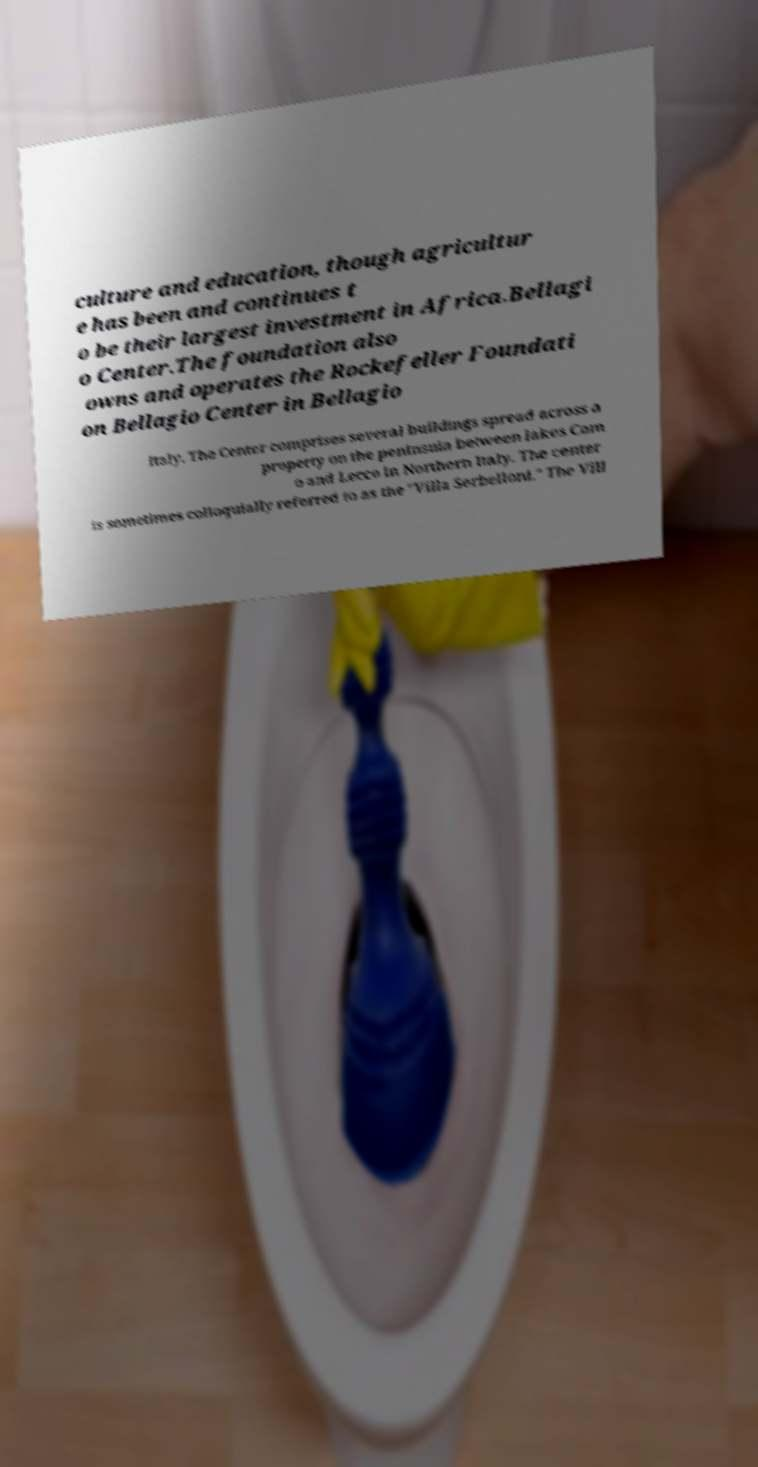Please identify and transcribe the text found in this image. culture and education, though agricultur e has been and continues t o be their largest investment in Africa.Bellagi o Center.The foundation also owns and operates the Rockefeller Foundati on Bellagio Center in Bellagio Italy. The Center comprises several buildings spread across a property on the peninsula between lakes Com o and Lecco in Northern Italy. The center is sometimes colloquially referred to as the "Villa Serbelloni." The Vill 